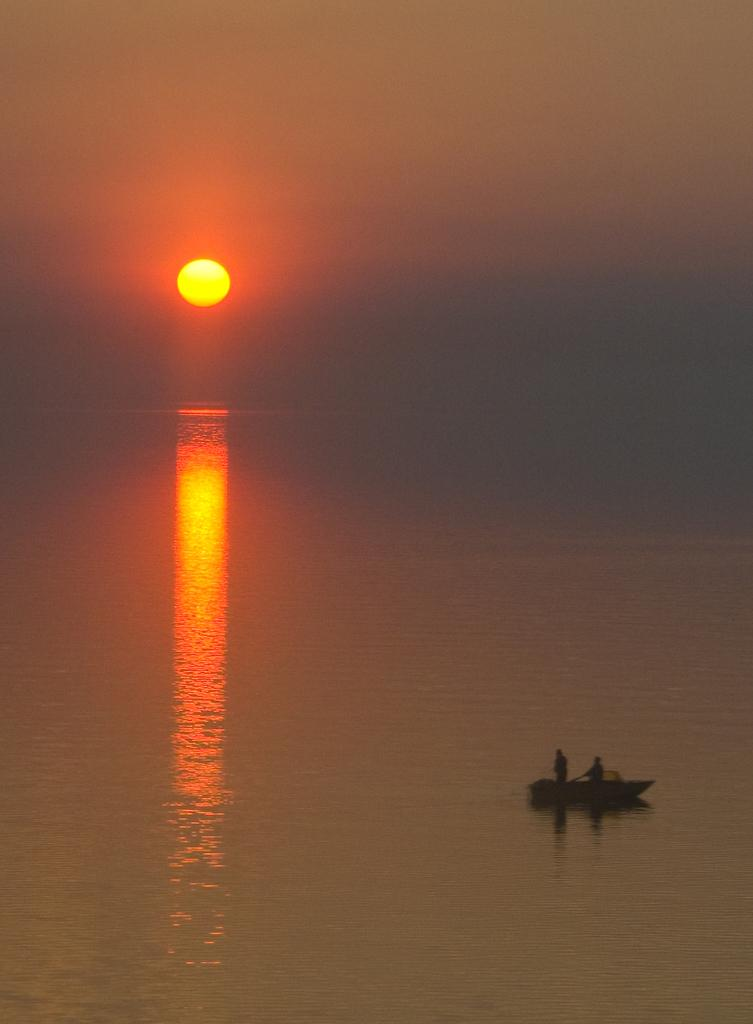What is the main subject of the image? The main subject of the image is a boat. Are there any people on the boat? Yes, there are people on the boat. What is the boat doing in the image? The boat is sailing on the water. What can be seen in the sky in the image? The sky is visible in the image, and the sun is visible in the sky. What type of basketball is being played on the boat in the image? There is no basketball or basketball game present in the image; it features a boat sailing on the water with people on board. 